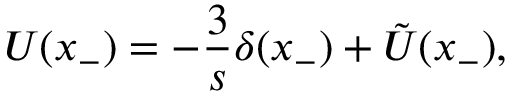Convert formula to latex. <formula><loc_0><loc_0><loc_500><loc_500>U ( x _ { - } ) = - \frac { 3 } { s } \delta ( x _ { - } ) + \tilde { U } ( x _ { - } ) ,</formula> 